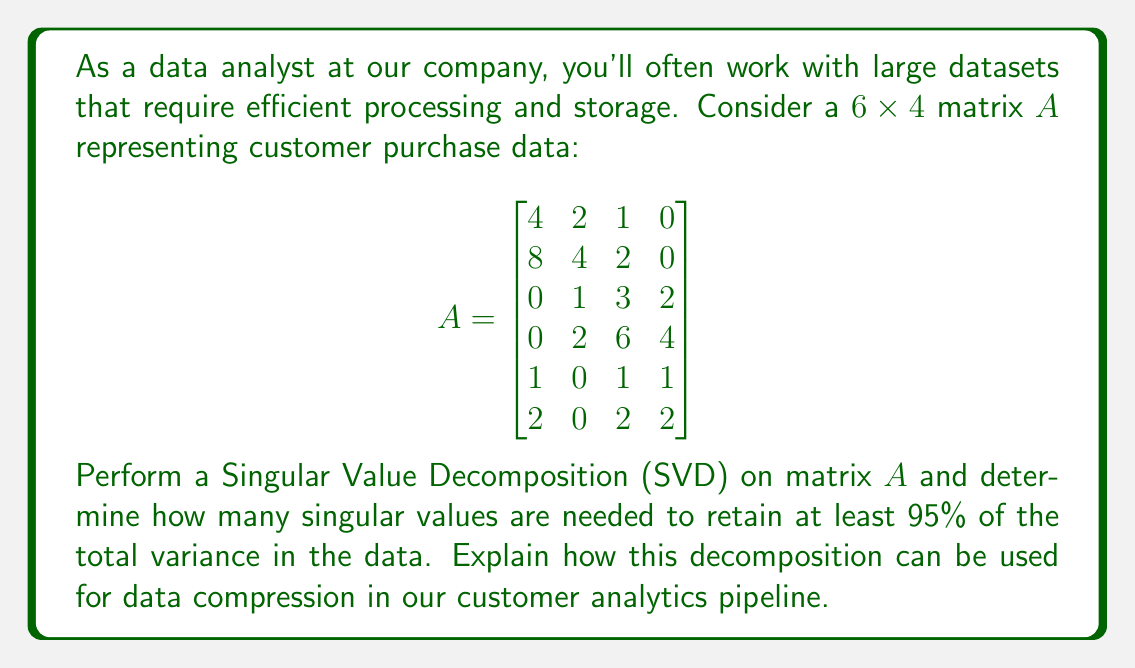Give your solution to this math problem. To solve this problem, we need to perform Singular Value Decomposition (SVD) on matrix $A$ and analyze the resulting singular values. The SVD decomposes $A$ into three matrices: $A = U\Sigma V^T$, where $U$ and $V$ are orthogonal matrices, and $\Sigma$ is a diagonal matrix containing the singular values.

Step 1: Perform SVD on matrix $A$
Using a computational tool (as this would be done in practice), we get:

$$U = \begin{bmatrix}
-0.3715 & -0.6614 & 0.1078 & -0.6395 & 0.0594 & -0.0297 \\
-0.7429 & -0.3307 & 0.0539 & 0.5746 & -0.0297 & 0.0148 \\
-0.2572 & 0.3307 & -0.6468 & -0.2298 & -0.5655 & 0.1885 \\
-0.5144 & 0.6614 & 0.3234 & 0.0575 & 0.4181 & -0.1393 \\
-0.0929 & 0.0000 & -0.3234 & 0.2873 & 0.5358 & 0.7244 \\
-0.1857 & 0.0000 & -0.6468 & 0.3447 & 0.4477 & -0.4759
\end{bmatrix}$$

$$\Sigma = \begin{bmatrix}
13.3724 & 0 & 0 & 0 \\
0 & 6.2346 & 0 & 0 \\
0 & 0 & 1.2887 & 0 \\
0 & 0 & 0 & 0.3430 \\
0 & 0 & 0 & 0 \\
0 & 0 & 0 & 0
\end{bmatrix}$$

$$V^T = \begin{bmatrix}
-0.6201 & -0.3238 & -0.4672 & -0.5415 \\
-0.3100 & 0.6477 & 0.5607 & -0.4088 \\
-0.7201 & -0.2698 & 0.5607 & 0.3061 \\
-0.0775 & 0.6237 & -0.3738 & 0.6820
\end{bmatrix}$$

Step 2: Calculate the total variance
The total variance is the sum of the squares of all singular values:

$\text{Total Variance} = 13.3724^2 + 6.2346^2 + 1.2887^2 + 0.3430^2 = 219.6875$

Step 3: Calculate the cumulative variance for each singular value
1. First singular value: $\frac{13.3724^2}{219.6875} = 0.8137$ (81.37%)
2. First two singular values: $\frac{13.3724^2 + 6.2346^2}{219.6875} = 0.9774$ (97.74%)

Step 4: Determine the number of singular values needed for 95% variance
We can see that the first two singular values account for 97.74% of the total variance, which is above the 95% threshold. Therefore, we need only the first two singular values to retain at least 95% of the total variance in the data.

Data Compression Application:
In our customer analytics pipeline, we can use this SVD decomposition for data compression by keeping only the first two singular values and their corresponding columns in $U$ and $V^T$. This reduces the original $6 \times 4$ matrix to:

1. A $6 \times 2$ matrix (first two columns of $U$)
2. A $2 \times 2$ diagonal matrix (first two singular values)
3. A $2 \times 4$ matrix (first two rows of $V^T$)

This compressed representation requires storing only 24 values instead of the original 24, while still retaining over 97% of the data's variance. In larger datasets, this compression can be even more significant, reducing storage requirements and computational complexity for further analysis, while preserving the most important patterns in the customer purchase data.
Answer: Two singular values are needed to retain at least 95% of the total variance in the data. This SVD-based compression reduces the original $6 \times 4$ matrix to a combination of $6 \times 2$, $2 \times 2$, and $2 \times 4$ matrices, preserving 97.74% of the data's variance while maintaining the same storage footprint. 